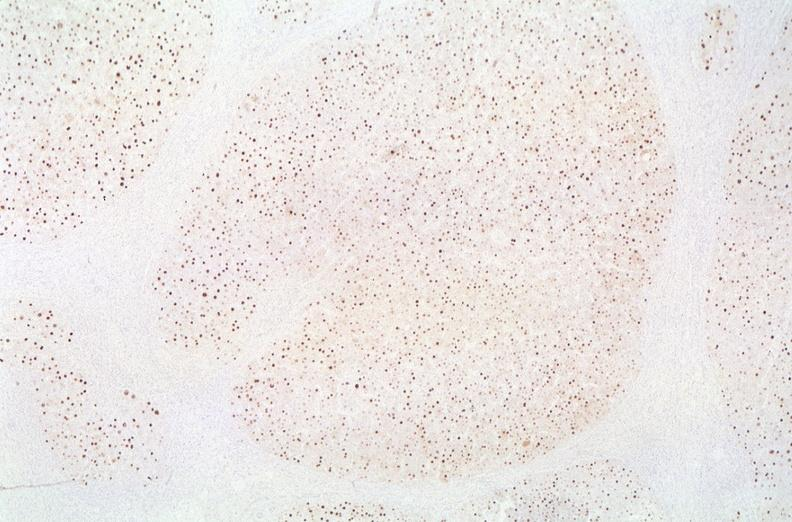s small intestine present?
Answer the question using a single word or phrase. No 